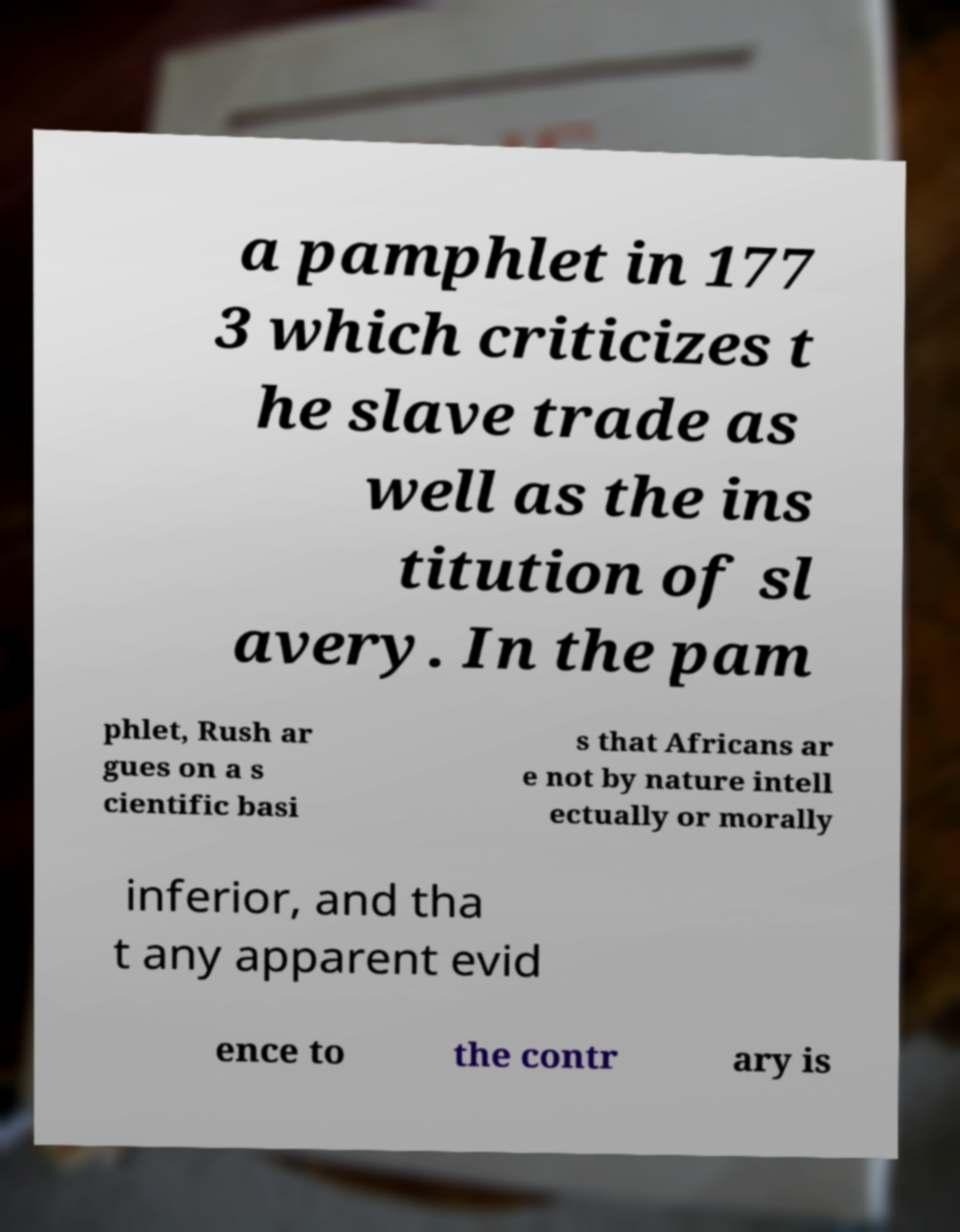Could you assist in decoding the text presented in this image and type it out clearly? a pamphlet in 177 3 which criticizes t he slave trade as well as the ins titution of sl avery. In the pam phlet, Rush ar gues on a s cientific basi s that Africans ar e not by nature intell ectually or morally inferior, and tha t any apparent evid ence to the contr ary is 